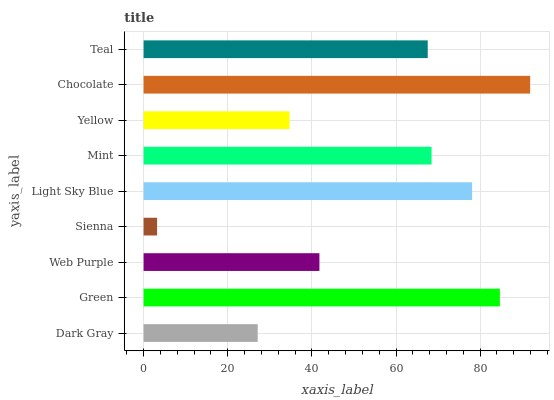Is Sienna the minimum?
Answer yes or no. Yes. Is Chocolate the maximum?
Answer yes or no. Yes. Is Green the minimum?
Answer yes or no. No. Is Green the maximum?
Answer yes or no. No. Is Green greater than Dark Gray?
Answer yes or no. Yes. Is Dark Gray less than Green?
Answer yes or no. Yes. Is Dark Gray greater than Green?
Answer yes or no. No. Is Green less than Dark Gray?
Answer yes or no. No. Is Teal the high median?
Answer yes or no. Yes. Is Teal the low median?
Answer yes or no. Yes. Is Dark Gray the high median?
Answer yes or no. No. Is Chocolate the low median?
Answer yes or no. No. 